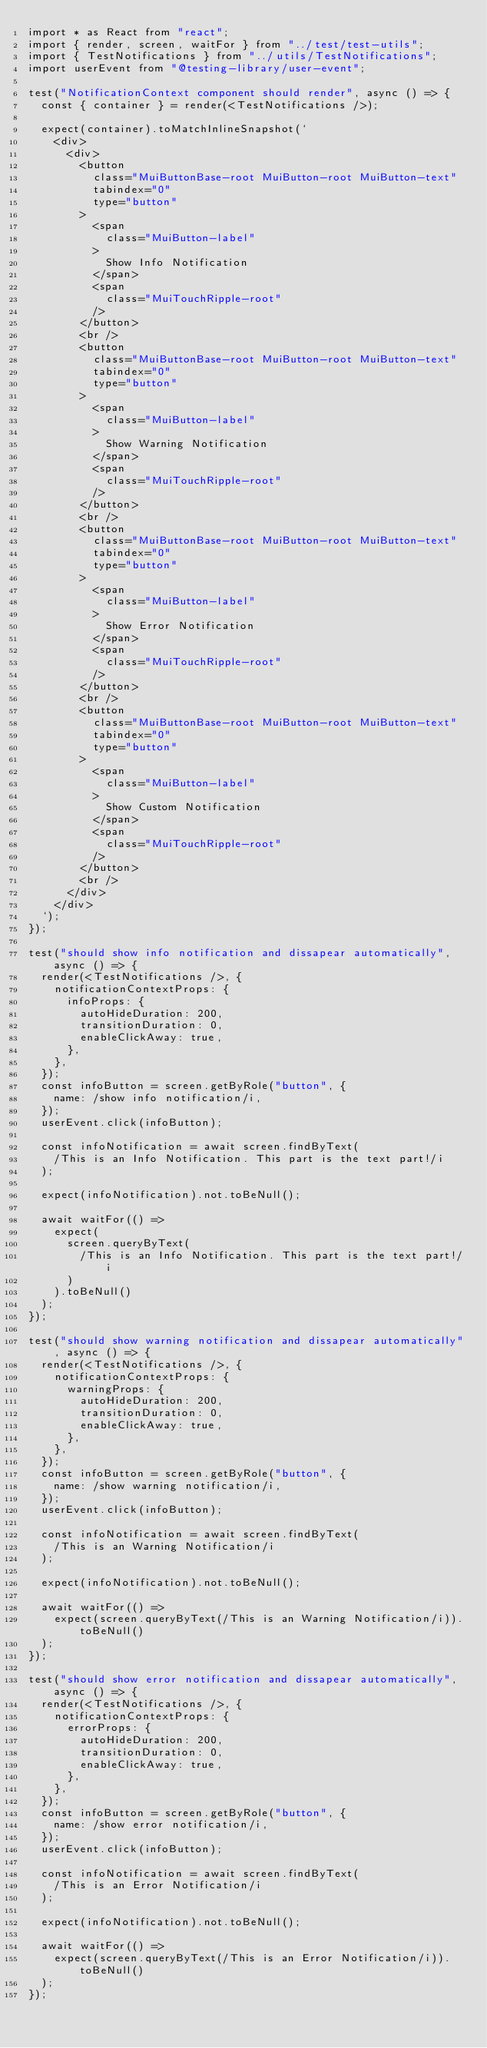<code> <loc_0><loc_0><loc_500><loc_500><_TypeScript_>import * as React from "react";
import { render, screen, waitFor } from "../test/test-utils";
import { TestNotifications } from "../utils/TestNotifications";
import userEvent from "@testing-library/user-event";

test("NotificationContext component should render", async () => {
  const { container } = render(<TestNotifications />);

  expect(container).toMatchInlineSnapshot(`
    <div>
      <div>
        <button
          class="MuiButtonBase-root MuiButton-root MuiButton-text"
          tabindex="0"
          type="button"
        >
          <span
            class="MuiButton-label"
          >
            Show Info Notification
          </span>
          <span
            class="MuiTouchRipple-root"
          />
        </button>
        <br />
        <button
          class="MuiButtonBase-root MuiButton-root MuiButton-text"
          tabindex="0"
          type="button"
        >
          <span
            class="MuiButton-label"
          >
            Show Warning Notification
          </span>
          <span
            class="MuiTouchRipple-root"
          />
        </button>
        <br />
        <button
          class="MuiButtonBase-root MuiButton-root MuiButton-text"
          tabindex="0"
          type="button"
        >
          <span
            class="MuiButton-label"
          >
            Show Error Notification
          </span>
          <span
            class="MuiTouchRipple-root"
          />
        </button>
        <br />
        <button
          class="MuiButtonBase-root MuiButton-root MuiButton-text"
          tabindex="0"
          type="button"
        >
          <span
            class="MuiButton-label"
          >
            Show Custom Notification
          </span>
          <span
            class="MuiTouchRipple-root"
          />
        </button>
        <br />
      </div>
    </div>
  `);
});

test("should show info notification and dissapear automatically", async () => {
  render(<TestNotifications />, {
    notificationContextProps: {
      infoProps: {
        autoHideDuration: 200,
        transitionDuration: 0,
        enableClickAway: true,
      },
    },
  });
  const infoButton = screen.getByRole("button", {
    name: /show info notification/i,
  });
  userEvent.click(infoButton);

  const infoNotification = await screen.findByText(
    /This is an Info Notification. This part is the text part!/i
  );

  expect(infoNotification).not.toBeNull();

  await waitFor(() =>
    expect(
      screen.queryByText(
        /This is an Info Notification. This part is the text part!/i
      )
    ).toBeNull()
  );
});

test("should show warning notification and dissapear automatically", async () => {
  render(<TestNotifications />, {
    notificationContextProps: {
      warningProps: {
        autoHideDuration: 200,
        transitionDuration: 0,
        enableClickAway: true,
      },
    },
  });
  const infoButton = screen.getByRole("button", {
    name: /show warning notification/i,
  });
  userEvent.click(infoButton);

  const infoNotification = await screen.findByText(
    /This is an Warning Notification/i
  );

  expect(infoNotification).not.toBeNull();

  await waitFor(() =>
    expect(screen.queryByText(/This is an Warning Notification/i)).toBeNull()
  );
});

test("should show error notification and dissapear automatically", async () => {
  render(<TestNotifications />, {
    notificationContextProps: {
      errorProps: {
        autoHideDuration: 200,
        transitionDuration: 0,
        enableClickAway: true,
      },
    },
  });
  const infoButton = screen.getByRole("button", {
    name: /show error notification/i,
  });
  userEvent.click(infoButton);

  const infoNotification = await screen.findByText(
    /This is an Error Notification/i
  );

  expect(infoNotification).not.toBeNull();

  await waitFor(() =>
    expect(screen.queryByText(/This is an Error Notification/i)).toBeNull()
  );
});
</code> 